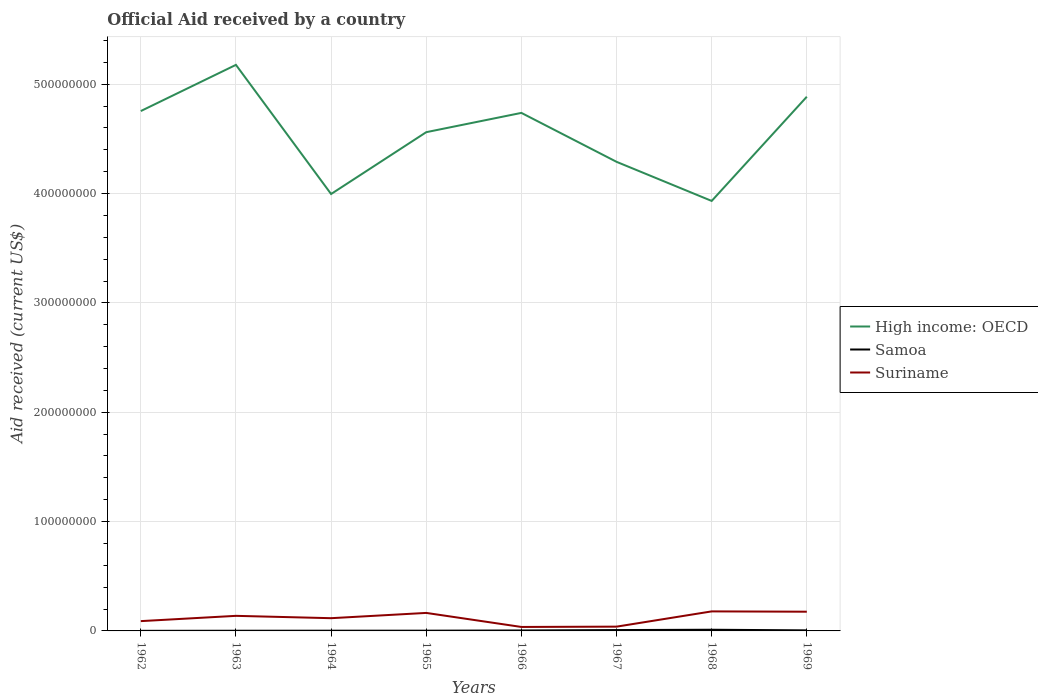How many different coloured lines are there?
Provide a short and direct response. 3. Is the number of lines equal to the number of legend labels?
Your answer should be very brief. Yes. Across all years, what is the maximum net official aid received in Samoa?
Give a very brief answer. 9.00e+04. In which year was the net official aid received in Suriname maximum?
Offer a terse response. 1966. What is the total net official aid received in Suriname in the graph?
Your answer should be very brief. -1.37e+07. What is the difference between the highest and the second highest net official aid received in Samoa?
Ensure brevity in your answer.  1.00e+06. What is the difference between the highest and the lowest net official aid received in Samoa?
Ensure brevity in your answer.  3. Is the net official aid received in High income: OECD strictly greater than the net official aid received in Suriname over the years?
Your answer should be very brief. No. How many lines are there?
Make the answer very short. 3. How many years are there in the graph?
Your response must be concise. 8. Does the graph contain grids?
Offer a very short reply. Yes. Where does the legend appear in the graph?
Give a very brief answer. Center right. How many legend labels are there?
Offer a terse response. 3. How are the legend labels stacked?
Offer a very short reply. Vertical. What is the title of the graph?
Offer a very short reply. Official Aid received by a country. Does "Tuvalu" appear as one of the legend labels in the graph?
Offer a very short reply. No. What is the label or title of the Y-axis?
Ensure brevity in your answer.  Aid received (current US$). What is the Aid received (current US$) of High income: OECD in 1962?
Provide a short and direct response. 4.75e+08. What is the Aid received (current US$) of Suriname in 1962?
Provide a succinct answer. 8.96e+06. What is the Aid received (current US$) in High income: OECD in 1963?
Ensure brevity in your answer.  5.18e+08. What is the Aid received (current US$) of Samoa in 1963?
Your answer should be very brief. 1.70e+05. What is the Aid received (current US$) in Suriname in 1963?
Provide a short and direct response. 1.38e+07. What is the Aid received (current US$) in High income: OECD in 1964?
Your answer should be very brief. 4.00e+08. What is the Aid received (current US$) of Samoa in 1964?
Provide a short and direct response. 2.10e+05. What is the Aid received (current US$) in Suriname in 1964?
Give a very brief answer. 1.16e+07. What is the Aid received (current US$) in High income: OECD in 1965?
Your answer should be compact. 4.56e+08. What is the Aid received (current US$) of Suriname in 1965?
Offer a very short reply. 1.65e+07. What is the Aid received (current US$) in High income: OECD in 1966?
Your answer should be very brief. 4.74e+08. What is the Aid received (current US$) of Suriname in 1966?
Ensure brevity in your answer.  3.63e+06. What is the Aid received (current US$) of High income: OECD in 1967?
Offer a very short reply. 4.29e+08. What is the Aid received (current US$) in Samoa in 1967?
Ensure brevity in your answer.  7.80e+05. What is the Aid received (current US$) in Suriname in 1967?
Your answer should be compact. 3.91e+06. What is the Aid received (current US$) of High income: OECD in 1968?
Keep it short and to the point. 3.93e+08. What is the Aid received (current US$) of Samoa in 1968?
Offer a terse response. 1.09e+06. What is the Aid received (current US$) in Suriname in 1968?
Ensure brevity in your answer.  1.79e+07. What is the Aid received (current US$) of High income: OECD in 1969?
Ensure brevity in your answer.  4.89e+08. What is the Aid received (current US$) of Samoa in 1969?
Keep it short and to the point. 5.10e+05. What is the Aid received (current US$) of Suriname in 1969?
Give a very brief answer. 1.76e+07. Across all years, what is the maximum Aid received (current US$) of High income: OECD?
Offer a very short reply. 5.18e+08. Across all years, what is the maximum Aid received (current US$) of Samoa?
Your answer should be compact. 1.09e+06. Across all years, what is the maximum Aid received (current US$) of Suriname?
Make the answer very short. 1.79e+07. Across all years, what is the minimum Aid received (current US$) of High income: OECD?
Give a very brief answer. 3.93e+08. Across all years, what is the minimum Aid received (current US$) in Samoa?
Ensure brevity in your answer.  9.00e+04. Across all years, what is the minimum Aid received (current US$) of Suriname?
Ensure brevity in your answer.  3.63e+06. What is the total Aid received (current US$) in High income: OECD in the graph?
Your response must be concise. 3.63e+09. What is the total Aid received (current US$) in Samoa in the graph?
Offer a very short reply. 3.50e+06. What is the total Aid received (current US$) of Suriname in the graph?
Ensure brevity in your answer.  9.38e+07. What is the difference between the Aid received (current US$) of High income: OECD in 1962 and that in 1963?
Your answer should be very brief. -4.22e+07. What is the difference between the Aid received (current US$) of Suriname in 1962 and that in 1963?
Provide a succinct answer. -4.83e+06. What is the difference between the Aid received (current US$) of High income: OECD in 1962 and that in 1964?
Give a very brief answer. 7.59e+07. What is the difference between the Aid received (current US$) of Samoa in 1962 and that in 1964?
Make the answer very short. -1.20e+05. What is the difference between the Aid received (current US$) of Suriname in 1962 and that in 1964?
Offer a very short reply. -2.69e+06. What is the difference between the Aid received (current US$) of High income: OECD in 1962 and that in 1965?
Your answer should be compact. 1.93e+07. What is the difference between the Aid received (current US$) in Suriname in 1962 and that in 1965?
Keep it short and to the point. -7.51e+06. What is the difference between the Aid received (current US$) in High income: OECD in 1962 and that in 1966?
Make the answer very short. 1.68e+06. What is the difference between the Aid received (current US$) of Samoa in 1962 and that in 1966?
Your answer should be very brief. -3.30e+05. What is the difference between the Aid received (current US$) in Suriname in 1962 and that in 1966?
Keep it short and to the point. 5.33e+06. What is the difference between the Aid received (current US$) in High income: OECD in 1962 and that in 1967?
Provide a short and direct response. 4.64e+07. What is the difference between the Aid received (current US$) in Samoa in 1962 and that in 1967?
Provide a short and direct response. -6.90e+05. What is the difference between the Aid received (current US$) of Suriname in 1962 and that in 1967?
Your response must be concise. 5.05e+06. What is the difference between the Aid received (current US$) in High income: OECD in 1962 and that in 1968?
Make the answer very short. 8.22e+07. What is the difference between the Aid received (current US$) of Samoa in 1962 and that in 1968?
Your response must be concise. -1.00e+06. What is the difference between the Aid received (current US$) of Suriname in 1962 and that in 1968?
Provide a short and direct response. -8.90e+06. What is the difference between the Aid received (current US$) of High income: OECD in 1962 and that in 1969?
Make the answer very short. -1.31e+07. What is the difference between the Aid received (current US$) in Samoa in 1962 and that in 1969?
Keep it short and to the point. -4.20e+05. What is the difference between the Aid received (current US$) of Suriname in 1962 and that in 1969?
Your answer should be very brief. -8.62e+06. What is the difference between the Aid received (current US$) of High income: OECD in 1963 and that in 1964?
Your answer should be compact. 1.18e+08. What is the difference between the Aid received (current US$) of Samoa in 1963 and that in 1964?
Your answer should be very brief. -4.00e+04. What is the difference between the Aid received (current US$) in Suriname in 1963 and that in 1964?
Give a very brief answer. 2.14e+06. What is the difference between the Aid received (current US$) of High income: OECD in 1963 and that in 1965?
Offer a terse response. 6.16e+07. What is the difference between the Aid received (current US$) of Suriname in 1963 and that in 1965?
Your answer should be very brief. -2.68e+06. What is the difference between the Aid received (current US$) of High income: OECD in 1963 and that in 1966?
Provide a short and direct response. 4.39e+07. What is the difference between the Aid received (current US$) in Samoa in 1963 and that in 1966?
Your response must be concise. -2.50e+05. What is the difference between the Aid received (current US$) in Suriname in 1963 and that in 1966?
Your answer should be compact. 1.02e+07. What is the difference between the Aid received (current US$) of High income: OECD in 1963 and that in 1967?
Ensure brevity in your answer.  8.87e+07. What is the difference between the Aid received (current US$) in Samoa in 1963 and that in 1967?
Your response must be concise. -6.10e+05. What is the difference between the Aid received (current US$) in Suriname in 1963 and that in 1967?
Ensure brevity in your answer.  9.88e+06. What is the difference between the Aid received (current US$) of High income: OECD in 1963 and that in 1968?
Ensure brevity in your answer.  1.24e+08. What is the difference between the Aid received (current US$) in Samoa in 1963 and that in 1968?
Give a very brief answer. -9.20e+05. What is the difference between the Aid received (current US$) of Suriname in 1963 and that in 1968?
Give a very brief answer. -4.07e+06. What is the difference between the Aid received (current US$) of High income: OECD in 1963 and that in 1969?
Your response must be concise. 2.91e+07. What is the difference between the Aid received (current US$) of Suriname in 1963 and that in 1969?
Provide a succinct answer. -3.79e+06. What is the difference between the Aid received (current US$) of High income: OECD in 1964 and that in 1965?
Ensure brevity in your answer.  -5.66e+07. What is the difference between the Aid received (current US$) of Suriname in 1964 and that in 1965?
Your answer should be very brief. -4.82e+06. What is the difference between the Aid received (current US$) of High income: OECD in 1964 and that in 1966?
Provide a succinct answer. -7.42e+07. What is the difference between the Aid received (current US$) of Suriname in 1964 and that in 1966?
Provide a short and direct response. 8.02e+06. What is the difference between the Aid received (current US$) in High income: OECD in 1964 and that in 1967?
Your response must be concise. -2.94e+07. What is the difference between the Aid received (current US$) of Samoa in 1964 and that in 1967?
Give a very brief answer. -5.70e+05. What is the difference between the Aid received (current US$) of Suriname in 1964 and that in 1967?
Your response must be concise. 7.74e+06. What is the difference between the Aid received (current US$) in High income: OECD in 1964 and that in 1968?
Your response must be concise. 6.33e+06. What is the difference between the Aid received (current US$) in Samoa in 1964 and that in 1968?
Your answer should be compact. -8.80e+05. What is the difference between the Aid received (current US$) in Suriname in 1964 and that in 1968?
Provide a succinct answer. -6.21e+06. What is the difference between the Aid received (current US$) in High income: OECD in 1964 and that in 1969?
Provide a succinct answer. -8.90e+07. What is the difference between the Aid received (current US$) in Suriname in 1964 and that in 1969?
Your response must be concise. -5.93e+06. What is the difference between the Aid received (current US$) in High income: OECD in 1965 and that in 1966?
Your answer should be compact. -1.76e+07. What is the difference between the Aid received (current US$) in Suriname in 1965 and that in 1966?
Ensure brevity in your answer.  1.28e+07. What is the difference between the Aid received (current US$) in High income: OECD in 1965 and that in 1967?
Give a very brief answer. 2.71e+07. What is the difference between the Aid received (current US$) in Samoa in 1965 and that in 1967?
Offer a very short reply. -5.50e+05. What is the difference between the Aid received (current US$) of Suriname in 1965 and that in 1967?
Your response must be concise. 1.26e+07. What is the difference between the Aid received (current US$) in High income: OECD in 1965 and that in 1968?
Provide a succinct answer. 6.29e+07. What is the difference between the Aid received (current US$) of Samoa in 1965 and that in 1968?
Offer a terse response. -8.60e+05. What is the difference between the Aid received (current US$) in Suriname in 1965 and that in 1968?
Ensure brevity in your answer.  -1.39e+06. What is the difference between the Aid received (current US$) of High income: OECD in 1965 and that in 1969?
Ensure brevity in your answer.  -3.24e+07. What is the difference between the Aid received (current US$) in Samoa in 1965 and that in 1969?
Keep it short and to the point. -2.80e+05. What is the difference between the Aid received (current US$) of Suriname in 1965 and that in 1969?
Offer a very short reply. -1.11e+06. What is the difference between the Aid received (current US$) in High income: OECD in 1966 and that in 1967?
Your answer should be very brief. 4.48e+07. What is the difference between the Aid received (current US$) in Samoa in 1966 and that in 1967?
Ensure brevity in your answer.  -3.60e+05. What is the difference between the Aid received (current US$) of Suriname in 1966 and that in 1967?
Your answer should be very brief. -2.80e+05. What is the difference between the Aid received (current US$) of High income: OECD in 1966 and that in 1968?
Give a very brief answer. 8.05e+07. What is the difference between the Aid received (current US$) in Samoa in 1966 and that in 1968?
Provide a succinct answer. -6.70e+05. What is the difference between the Aid received (current US$) of Suriname in 1966 and that in 1968?
Give a very brief answer. -1.42e+07. What is the difference between the Aid received (current US$) in High income: OECD in 1966 and that in 1969?
Your response must be concise. -1.48e+07. What is the difference between the Aid received (current US$) in Suriname in 1966 and that in 1969?
Your answer should be very brief. -1.40e+07. What is the difference between the Aid received (current US$) of High income: OECD in 1967 and that in 1968?
Your answer should be very brief. 3.58e+07. What is the difference between the Aid received (current US$) of Samoa in 1967 and that in 1968?
Offer a terse response. -3.10e+05. What is the difference between the Aid received (current US$) in Suriname in 1967 and that in 1968?
Ensure brevity in your answer.  -1.40e+07. What is the difference between the Aid received (current US$) of High income: OECD in 1967 and that in 1969?
Offer a very short reply. -5.95e+07. What is the difference between the Aid received (current US$) in Samoa in 1967 and that in 1969?
Your answer should be very brief. 2.70e+05. What is the difference between the Aid received (current US$) of Suriname in 1967 and that in 1969?
Provide a succinct answer. -1.37e+07. What is the difference between the Aid received (current US$) in High income: OECD in 1968 and that in 1969?
Offer a terse response. -9.53e+07. What is the difference between the Aid received (current US$) of Samoa in 1968 and that in 1969?
Provide a short and direct response. 5.80e+05. What is the difference between the Aid received (current US$) of High income: OECD in 1962 and the Aid received (current US$) of Samoa in 1963?
Offer a terse response. 4.75e+08. What is the difference between the Aid received (current US$) in High income: OECD in 1962 and the Aid received (current US$) in Suriname in 1963?
Your answer should be compact. 4.62e+08. What is the difference between the Aid received (current US$) in Samoa in 1962 and the Aid received (current US$) in Suriname in 1963?
Provide a succinct answer. -1.37e+07. What is the difference between the Aid received (current US$) of High income: OECD in 1962 and the Aid received (current US$) of Samoa in 1964?
Provide a succinct answer. 4.75e+08. What is the difference between the Aid received (current US$) in High income: OECD in 1962 and the Aid received (current US$) in Suriname in 1964?
Keep it short and to the point. 4.64e+08. What is the difference between the Aid received (current US$) of Samoa in 1962 and the Aid received (current US$) of Suriname in 1964?
Keep it short and to the point. -1.16e+07. What is the difference between the Aid received (current US$) in High income: OECD in 1962 and the Aid received (current US$) in Samoa in 1965?
Keep it short and to the point. 4.75e+08. What is the difference between the Aid received (current US$) in High income: OECD in 1962 and the Aid received (current US$) in Suriname in 1965?
Your response must be concise. 4.59e+08. What is the difference between the Aid received (current US$) in Samoa in 1962 and the Aid received (current US$) in Suriname in 1965?
Provide a succinct answer. -1.64e+07. What is the difference between the Aid received (current US$) in High income: OECD in 1962 and the Aid received (current US$) in Samoa in 1966?
Offer a very short reply. 4.75e+08. What is the difference between the Aid received (current US$) of High income: OECD in 1962 and the Aid received (current US$) of Suriname in 1966?
Your answer should be compact. 4.72e+08. What is the difference between the Aid received (current US$) in Samoa in 1962 and the Aid received (current US$) in Suriname in 1966?
Offer a terse response. -3.54e+06. What is the difference between the Aid received (current US$) of High income: OECD in 1962 and the Aid received (current US$) of Samoa in 1967?
Keep it short and to the point. 4.75e+08. What is the difference between the Aid received (current US$) of High income: OECD in 1962 and the Aid received (current US$) of Suriname in 1967?
Ensure brevity in your answer.  4.72e+08. What is the difference between the Aid received (current US$) of Samoa in 1962 and the Aid received (current US$) of Suriname in 1967?
Make the answer very short. -3.82e+06. What is the difference between the Aid received (current US$) in High income: OECD in 1962 and the Aid received (current US$) in Samoa in 1968?
Your answer should be compact. 4.74e+08. What is the difference between the Aid received (current US$) in High income: OECD in 1962 and the Aid received (current US$) in Suriname in 1968?
Your response must be concise. 4.58e+08. What is the difference between the Aid received (current US$) in Samoa in 1962 and the Aid received (current US$) in Suriname in 1968?
Your answer should be very brief. -1.78e+07. What is the difference between the Aid received (current US$) of High income: OECD in 1962 and the Aid received (current US$) of Samoa in 1969?
Your answer should be compact. 4.75e+08. What is the difference between the Aid received (current US$) in High income: OECD in 1962 and the Aid received (current US$) in Suriname in 1969?
Your answer should be very brief. 4.58e+08. What is the difference between the Aid received (current US$) in Samoa in 1962 and the Aid received (current US$) in Suriname in 1969?
Keep it short and to the point. -1.75e+07. What is the difference between the Aid received (current US$) of High income: OECD in 1963 and the Aid received (current US$) of Samoa in 1964?
Your answer should be very brief. 5.18e+08. What is the difference between the Aid received (current US$) in High income: OECD in 1963 and the Aid received (current US$) in Suriname in 1964?
Your answer should be compact. 5.06e+08. What is the difference between the Aid received (current US$) in Samoa in 1963 and the Aid received (current US$) in Suriname in 1964?
Your answer should be compact. -1.15e+07. What is the difference between the Aid received (current US$) in High income: OECD in 1963 and the Aid received (current US$) in Samoa in 1965?
Give a very brief answer. 5.18e+08. What is the difference between the Aid received (current US$) in High income: OECD in 1963 and the Aid received (current US$) in Suriname in 1965?
Provide a succinct answer. 5.01e+08. What is the difference between the Aid received (current US$) of Samoa in 1963 and the Aid received (current US$) of Suriname in 1965?
Offer a terse response. -1.63e+07. What is the difference between the Aid received (current US$) of High income: OECD in 1963 and the Aid received (current US$) of Samoa in 1966?
Offer a very short reply. 5.17e+08. What is the difference between the Aid received (current US$) of High income: OECD in 1963 and the Aid received (current US$) of Suriname in 1966?
Provide a short and direct response. 5.14e+08. What is the difference between the Aid received (current US$) in Samoa in 1963 and the Aid received (current US$) in Suriname in 1966?
Offer a terse response. -3.46e+06. What is the difference between the Aid received (current US$) of High income: OECD in 1963 and the Aid received (current US$) of Samoa in 1967?
Offer a very short reply. 5.17e+08. What is the difference between the Aid received (current US$) of High income: OECD in 1963 and the Aid received (current US$) of Suriname in 1967?
Make the answer very short. 5.14e+08. What is the difference between the Aid received (current US$) in Samoa in 1963 and the Aid received (current US$) in Suriname in 1967?
Your response must be concise. -3.74e+06. What is the difference between the Aid received (current US$) of High income: OECD in 1963 and the Aid received (current US$) of Samoa in 1968?
Your answer should be compact. 5.17e+08. What is the difference between the Aid received (current US$) of High income: OECD in 1963 and the Aid received (current US$) of Suriname in 1968?
Provide a short and direct response. 5.00e+08. What is the difference between the Aid received (current US$) of Samoa in 1963 and the Aid received (current US$) of Suriname in 1968?
Ensure brevity in your answer.  -1.77e+07. What is the difference between the Aid received (current US$) of High income: OECD in 1963 and the Aid received (current US$) of Samoa in 1969?
Provide a succinct answer. 5.17e+08. What is the difference between the Aid received (current US$) in High income: OECD in 1963 and the Aid received (current US$) in Suriname in 1969?
Give a very brief answer. 5.00e+08. What is the difference between the Aid received (current US$) in Samoa in 1963 and the Aid received (current US$) in Suriname in 1969?
Your response must be concise. -1.74e+07. What is the difference between the Aid received (current US$) in High income: OECD in 1964 and the Aid received (current US$) in Samoa in 1965?
Keep it short and to the point. 3.99e+08. What is the difference between the Aid received (current US$) in High income: OECD in 1964 and the Aid received (current US$) in Suriname in 1965?
Provide a succinct answer. 3.83e+08. What is the difference between the Aid received (current US$) of Samoa in 1964 and the Aid received (current US$) of Suriname in 1965?
Your answer should be very brief. -1.63e+07. What is the difference between the Aid received (current US$) in High income: OECD in 1964 and the Aid received (current US$) in Samoa in 1966?
Give a very brief answer. 3.99e+08. What is the difference between the Aid received (current US$) in High income: OECD in 1964 and the Aid received (current US$) in Suriname in 1966?
Your response must be concise. 3.96e+08. What is the difference between the Aid received (current US$) of Samoa in 1964 and the Aid received (current US$) of Suriname in 1966?
Offer a very short reply. -3.42e+06. What is the difference between the Aid received (current US$) of High income: OECD in 1964 and the Aid received (current US$) of Samoa in 1967?
Your answer should be very brief. 3.99e+08. What is the difference between the Aid received (current US$) of High income: OECD in 1964 and the Aid received (current US$) of Suriname in 1967?
Your answer should be compact. 3.96e+08. What is the difference between the Aid received (current US$) of Samoa in 1964 and the Aid received (current US$) of Suriname in 1967?
Give a very brief answer. -3.70e+06. What is the difference between the Aid received (current US$) of High income: OECD in 1964 and the Aid received (current US$) of Samoa in 1968?
Your answer should be very brief. 3.99e+08. What is the difference between the Aid received (current US$) in High income: OECD in 1964 and the Aid received (current US$) in Suriname in 1968?
Your response must be concise. 3.82e+08. What is the difference between the Aid received (current US$) of Samoa in 1964 and the Aid received (current US$) of Suriname in 1968?
Provide a succinct answer. -1.76e+07. What is the difference between the Aid received (current US$) in High income: OECD in 1964 and the Aid received (current US$) in Samoa in 1969?
Give a very brief answer. 3.99e+08. What is the difference between the Aid received (current US$) of High income: OECD in 1964 and the Aid received (current US$) of Suriname in 1969?
Offer a terse response. 3.82e+08. What is the difference between the Aid received (current US$) of Samoa in 1964 and the Aid received (current US$) of Suriname in 1969?
Give a very brief answer. -1.74e+07. What is the difference between the Aid received (current US$) in High income: OECD in 1965 and the Aid received (current US$) in Samoa in 1966?
Your response must be concise. 4.56e+08. What is the difference between the Aid received (current US$) in High income: OECD in 1965 and the Aid received (current US$) in Suriname in 1966?
Your answer should be very brief. 4.53e+08. What is the difference between the Aid received (current US$) in Samoa in 1965 and the Aid received (current US$) in Suriname in 1966?
Your answer should be compact. -3.40e+06. What is the difference between the Aid received (current US$) of High income: OECD in 1965 and the Aid received (current US$) of Samoa in 1967?
Keep it short and to the point. 4.55e+08. What is the difference between the Aid received (current US$) of High income: OECD in 1965 and the Aid received (current US$) of Suriname in 1967?
Ensure brevity in your answer.  4.52e+08. What is the difference between the Aid received (current US$) in Samoa in 1965 and the Aid received (current US$) in Suriname in 1967?
Your answer should be very brief. -3.68e+06. What is the difference between the Aid received (current US$) in High income: OECD in 1965 and the Aid received (current US$) in Samoa in 1968?
Give a very brief answer. 4.55e+08. What is the difference between the Aid received (current US$) of High income: OECD in 1965 and the Aid received (current US$) of Suriname in 1968?
Provide a succinct answer. 4.38e+08. What is the difference between the Aid received (current US$) of Samoa in 1965 and the Aid received (current US$) of Suriname in 1968?
Your answer should be very brief. -1.76e+07. What is the difference between the Aid received (current US$) in High income: OECD in 1965 and the Aid received (current US$) in Samoa in 1969?
Offer a terse response. 4.56e+08. What is the difference between the Aid received (current US$) of High income: OECD in 1965 and the Aid received (current US$) of Suriname in 1969?
Give a very brief answer. 4.39e+08. What is the difference between the Aid received (current US$) of Samoa in 1965 and the Aid received (current US$) of Suriname in 1969?
Provide a short and direct response. -1.74e+07. What is the difference between the Aid received (current US$) in High income: OECD in 1966 and the Aid received (current US$) in Samoa in 1967?
Your answer should be compact. 4.73e+08. What is the difference between the Aid received (current US$) of High income: OECD in 1966 and the Aid received (current US$) of Suriname in 1967?
Offer a terse response. 4.70e+08. What is the difference between the Aid received (current US$) of Samoa in 1966 and the Aid received (current US$) of Suriname in 1967?
Provide a succinct answer. -3.49e+06. What is the difference between the Aid received (current US$) of High income: OECD in 1966 and the Aid received (current US$) of Samoa in 1968?
Keep it short and to the point. 4.73e+08. What is the difference between the Aid received (current US$) of High income: OECD in 1966 and the Aid received (current US$) of Suriname in 1968?
Keep it short and to the point. 4.56e+08. What is the difference between the Aid received (current US$) of Samoa in 1966 and the Aid received (current US$) of Suriname in 1968?
Offer a terse response. -1.74e+07. What is the difference between the Aid received (current US$) in High income: OECD in 1966 and the Aid received (current US$) in Samoa in 1969?
Provide a succinct answer. 4.73e+08. What is the difference between the Aid received (current US$) in High income: OECD in 1966 and the Aid received (current US$) in Suriname in 1969?
Your response must be concise. 4.56e+08. What is the difference between the Aid received (current US$) in Samoa in 1966 and the Aid received (current US$) in Suriname in 1969?
Your response must be concise. -1.72e+07. What is the difference between the Aid received (current US$) in High income: OECD in 1967 and the Aid received (current US$) in Samoa in 1968?
Your answer should be compact. 4.28e+08. What is the difference between the Aid received (current US$) in High income: OECD in 1967 and the Aid received (current US$) in Suriname in 1968?
Your response must be concise. 4.11e+08. What is the difference between the Aid received (current US$) in Samoa in 1967 and the Aid received (current US$) in Suriname in 1968?
Provide a short and direct response. -1.71e+07. What is the difference between the Aid received (current US$) of High income: OECD in 1967 and the Aid received (current US$) of Samoa in 1969?
Offer a terse response. 4.29e+08. What is the difference between the Aid received (current US$) of High income: OECD in 1967 and the Aid received (current US$) of Suriname in 1969?
Your response must be concise. 4.11e+08. What is the difference between the Aid received (current US$) in Samoa in 1967 and the Aid received (current US$) in Suriname in 1969?
Provide a succinct answer. -1.68e+07. What is the difference between the Aid received (current US$) of High income: OECD in 1968 and the Aid received (current US$) of Samoa in 1969?
Give a very brief answer. 3.93e+08. What is the difference between the Aid received (current US$) of High income: OECD in 1968 and the Aid received (current US$) of Suriname in 1969?
Ensure brevity in your answer.  3.76e+08. What is the difference between the Aid received (current US$) in Samoa in 1968 and the Aid received (current US$) in Suriname in 1969?
Offer a very short reply. -1.65e+07. What is the average Aid received (current US$) in High income: OECD per year?
Keep it short and to the point. 4.54e+08. What is the average Aid received (current US$) in Samoa per year?
Your answer should be compact. 4.38e+05. What is the average Aid received (current US$) of Suriname per year?
Provide a succinct answer. 1.17e+07. In the year 1962, what is the difference between the Aid received (current US$) of High income: OECD and Aid received (current US$) of Samoa?
Give a very brief answer. 4.75e+08. In the year 1962, what is the difference between the Aid received (current US$) in High income: OECD and Aid received (current US$) in Suriname?
Make the answer very short. 4.67e+08. In the year 1962, what is the difference between the Aid received (current US$) of Samoa and Aid received (current US$) of Suriname?
Provide a short and direct response. -8.87e+06. In the year 1963, what is the difference between the Aid received (current US$) of High income: OECD and Aid received (current US$) of Samoa?
Offer a terse response. 5.18e+08. In the year 1963, what is the difference between the Aid received (current US$) in High income: OECD and Aid received (current US$) in Suriname?
Give a very brief answer. 5.04e+08. In the year 1963, what is the difference between the Aid received (current US$) of Samoa and Aid received (current US$) of Suriname?
Your answer should be compact. -1.36e+07. In the year 1964, what is the difference between the Aid received (current US$) of High income: OECD and Aid received (current US$) of Samoa?
Ensure brevity in your answer.  3.99e+08. In the year 1964, what is the difference between the Aid received (current US$) in High income: OECD and Aid received (current US$) in Suriname?
Keep it short and to the point. 3.88e+08. In the year 1964, what is the difference between the Aid received (current US$) in Samoa and Aid received (current US$) in Suriname?
Provide a short and direct response. -1.14e+07. In the year 1965, what is the difference between the Aid received (current US$) in High income: OECD and Aid received (current US$) in Samoa?
Keep it short and to the point. 4.56e+08. In the year 1965, what is the difference between the Aid received (current US$) of High income: OECD and Aid received (current US$) of Suriname?
Your response must be concise. 4.40e+08. In the year 1965, what is the difference between the Aid received (current US$) of Samoa and Aid received (current US$) of Suriname?
Your answer should be very brief. -1.62e+07. In the year 1966, what is the difference between the Aid received (current US$) of High income: OECD and Aid received (current US$) of Samoa?
Offer a terse response. 4.73e+08. In the year 1966, what is the difference between the Aid received (current US$) of High income: OECD and Aid received (current US$) of Suriname?
Provide a short and direct response. 4.70e+08. In the year 1966, what is the difference between the Aid received (current US$) in Samoa and Aid received (current US$) in Suriname?
Keep it short and to the point. -3.21e+06. In the year 1967, what is the difference between the Aid received (current US$) in High income: OECD and Aid received (current US$) in Samoa?
Offer a terse response. 4.28e+08. In the year 1967, what is the difference between the Aid received (current US$) of High income: OECD and Aid received (current US$) of Suriname?
Keep it short and to the point. 4.25e+08. In the year 1967, what is the difference between the Aid received (current US$) of Samoa and Aid received (current US$) of Suriname?
Provide a short and direct response. -3.13e+06. In the year 1968, what is the difference between the Aid received (current US$) of High income: OECD and Aid received (current US$) of Samoa?
Provide a short and direct response. 3.92e+08. In the year 1968, what is the difference between the Aid received (current US$) in High income: OECD and Aid received (current US$) in Suriname?
Provide a succinct answer. 3.75e+08. In the year 1968, what is the difference between the Aid received (current US$) of Samoa and Aid received (current US$) of Suriname?
Your answer should be very brief. -1.68e+07. In the year 1969, what is the difference between the Aid received (current US$) of High income: OECD and Aid received (current US$) of Samoa?
Your answer should be very brief. 4.88e+08. In the year 1969, what is the difference between the Aid received (current US$) of High income: OECD and Aid received (current US$) of Suriname?
Keep it short and to the point. 4.71e+08. In the year 1969, what is the difference between the Aid received (current US$) in Samoa and Aid received (current US$) in Suriname?
Offer a very short reply. -1.71e+07. What is the ratio of the Aid received (current US$) in High income: OECD in 1962 to that in 1963?
Your response must be concise. 0.92. What is the ratio of the Aid received (current US$) in Samoa in 1962 to that in 1963?
Keep it short and to the point. 0.53. What is the ratio of the Aid received (current US$) of Suriname in 1962 to that in 1963?
Ensure brevity in your answer.  0.65. What is the ratio of the Aid received (current US$) of High income: OECD in 1962 to that in 1964?
Provide a short and direct response. 1.19. What is the ratio of the Aid received (current US$) in Samoa in 1962 to that in 1964?
Offer a terse response. 0.43. What is the ratio of the Aid received (current US$) in Suriname in 1962 to that in 1964?
Provide a succinct answer. 0.77. What is the ratio of the Aid received (current US$) in High income: OECD in 1962 to that in 1965?
Your answer should be very brief. 1.04. What is the ratio of the Aid received (current US$) in Samoa in 1962 to that in 1965?
Offer a very short reply. 0.39. What is the ratio of the Aid received (current US$) in Suriname in 1962 to that in 1965?
Provide a short and direct response. 0.54. What is the ratio of the Aid received (current US$) of High income: OECD in 1962 to that in 1966?
Your answer should be very brief. 1. What is the ratio of the Aid received (current US$) in Samoa in 1962 to that in 1966?
Ensure brevity in your answer.  0.21. What is the ratio of the Aid received (current US$) in Suriname in 1962 to that in 1966?
Your answer should be very brief. 2.47. What is the ratio of the Aid received (current US$) of High income: OECD in 1962 to that in 1967?
Your response must be concise. 1.11. What is the ratio of the Aid received (current US$) in Samoa in 1962 to that in 1967?
Give a very brief answer. 0.12. What is the ratio of the Aid received (current US$) in Suriname in 1962 to that in 1967?
Offer a terse response. 2.29. What is the ratio of the Aid received (current US$) of High income: OECD in 1962 to that in 1968?
Provide a succinct answer. 1.21. What is the ratio of the Aid received (current US$) in Samoa in 1962 to that in 1968?
Provide a short and direct response. 0.08. What is the ratio of the Aid received (current US$) in Suriname in 1962 to that in 1968?
Give a very brief answer. 0.5. What is the ratio of the Aid received (current US$) in High income: OECD in 1962 to that in 1969?
Provide a succinct answer. 0.97. What is the ratio of the Aid received (current US$) in Samoa in 1962 to that in 1969?
Give a very brief answer. 0.18. What is the ratio of the Aid received (current US$) in Suriname in 1962 to that in 1969?
Make the answer very short. 0.51. What is the ratio of the Aid received (current US$) of High income: OECD in 1963 to that in 1964?
Provide a short and direct response. 1.3. What is the ratio of the Aid received (current US$) of Samoa in 1963 to that in 1964?
Make the answer very short. 0.81. What is the ratio of the Aid received (current US$) of Suriname in 1963 to that in 1964?
Ensure brevity in your answer.  1.18. What is the ratio of the Aid received (current US$) of High income: OECD in 1963 to that in 1965?
Keep it short and to the point. 1.13. What is the ratio of the Aid received (current US$) in Samoa in 1963 to that in 1965?
Provide a succinct answer. 0.74. What is the ratio of the Aid received (current US$) in Suriname in 1963 to that in 1965?
Offer a terse response. 0.84. What is the ratio of the Aid received (current US$) in High income: OECD in 1963 to that in 1966?
Your answer should be compact. 1.09. What is the ratio of the Aid received (current US$) in Samoa in 1963 to that in 1966?
Provide a succinct answer. 0.4. What is the ratio of the Aid received (current US$) in Suriname in 1963 to that in 1966?
Keep it short and to the point. 3.8. What is the ratio of the Aid received (current US$) in High income: OECD in 1963 to that in 1967?
Offer a terse response. 1.21. What is the ratio of the Aid received (current US$) of Samoa in 1963 to that in 1967?
Ensure brevity in your answer.  0.22. What is the ratio of the Aid received (current US$) in Suriname in 1963 to that in 1967?
Your answer should be compact. 3.53. What is the ratio of the Aid received (current US$) in High income: OECD in 1963 to that in 1968?
Provide a succinct answer. 1.32. What is the ratio of the Aid received (current US$) of Samoa in 1963 to that in 1968?
Give a very brief answer. 0.16. What is the ratio of the Aid received (current US$) of Suriname in 1963 to that in 1968?
Offer a terse response. 0.77. What is the ratio of the Aid received (current US$) in High income: OECD in 1963 to that in 1969?
Your response must be concise. 1.06. What is the ratio of the Aid received (current US$) in Samoa in 1963 to that in 1969?
Provide a succinct answer. 0.33. What is the ratio of the Aid received (current US$) in Suriname in 1963 to that in 1969?
Your answer should be very brief. 0.78. What is the ratio of the Aid received (current US$) in High income: OECD in 1964 to that in 1965?
Make the answer very short. 0.88. What is the ratio of the Aid received (current US$) in Suriname in 1964 to that in 1965?
Your answer should be very brief. 0.71. What is the ratio of the Aid received (current US$) in High income: OECD in 1964 to that in 1966?
Offer a very short reply. 0.84. What is the ratio of the Aid received (current US$) of Suriname in 1964 to that in 1966?
Provide a short and direct response. 3.21. What is the ratio of the Aid received (current US$) of High income: OECD in 1964 to that in 1967?
Your response must be concise. 0.93. What is the ratio of the Aid received (current US$) of Samoa in 1964 to that in 1967?
Ensure brevity in your answer.  0.27. What is the ratio of the Aid received (current US$) of Suriname in 1964 to that in 1967?
Offer a terse response. 2.98. What is the ratio of the Aid received (current US$) in High income: OECD in 1964 to that in 1968?
Offer a terse response. 1.02. What is the ratio of the Aid received (current US$) in Samoa in 1964 to that in 1968?
Make the answer very short. 0.19. What is the ratio of the Aid received (current US$) of Suriname in 1964 to that in 1968?
Your answer should be compact. 0.65. What is the ratio of the Aid received (current US$) of High income: OECD in 1964 to that in 1969?
Provide a short and direct response. 0.82. What is the ratio of the Aid received (current US$) of Samoa in 1964 to that in 1969?
Your answer should be very brief. 0.41. What is the ratio of the Aid received (current US$) of Suriname in 1964 to that in 1969?
Offer a terse response. 0.66. What is the ratio of the Aid received (current US$) of High income: OECD in 1965 to that in 1966?
Make the answer very short. 0.96. What is the ratio of the Aid received (current US$) of Samoa in 1965 to that in 1966?
Provide a succinct answer. 0.55. What is the ratio of the Aid received (current US$) in Suriname in 1965 to that in 1966?
Offer a terse response. 4.54. What is the ratio of the Aid received (current US$) of High income: OECD in 1965 to that in 1967?
Your response must be concise. 1.06. What is the ratio of the Aid received (current US$) in Samoa in 1965 to that in 1967?
Your answer should be compact. 0.29. What is the ratio of the Aid received (current US$) of Suriname in 1965 to that in 1967?
Make the answer very short. 4.21. What is the ratio of the Aid received (current US$) in High income: OECD in 1965 to that in 1968?
Give a very brief answer. 1.16. What is the ratio of the Aid received (current US$) in Samoa in 1965 to that in 1968?
Your response must be concise. 0.21. What is the ratio of the Aid received (current US$) of Suriname in 1965 to that in 1968?
Provide a succinct answer. 0.92. What is the ratio of the Aid received (current US$) in High income: OECD in 1965 to that in 1969?
Your answer should be very brief. 0.93. What is the ratio of the Aid received (current US$) in Samoa in 1965 to that in 1969?
Offer a very short reply. 0.45. What is the ratio of the Aid received (current US$) of Suriname in 1965 to that in 1969?
Make the answer very short. 0.94. What is the ratio of the Aid received (current US$) of High income: OECD in 1966 to that in 1967?
Provide a short and direct response. 1.1. What is the ratio of the Aid received (current US$) of Samoa in 1966 to that in 1967?
Your answer should be very brief. 0.54. What is the ratio of the Aid received (current US$) in Suriname in 1966 to that in 1967?
Make the answer very short. 0.93. What is the ratio of the Aid received (current US$) in High income: OECD in 1966 to that in 1968?
Ensure brevity in your answer.  1.2. What is the ratio of the Aid received (current US$) in Samoa in 1966 to that in 1968?
Offer a terse response. 0.39. What is the ratio of the Aid received (current US$) in Suriname in 1966 to that in 1968?
Offer a terse response. 0.2. What is the ratio of the Aid received (current US$) in High income: OECD in 1966 to that in 1969?
Make the answer very short. 0.97. What is the ratio of the Aid received (current US$) in Samoa in 1966 to that in 1969?
Keep it short and to the point. 0.82. What is the ratio of the Aid received (current US$) in Suriname in 1966 to that in 1969?
Keep it short and to the point. 0.21. What is the ratio of the Aid received (current US$) in High income: OECD in 1967 to that in 1968?
Your response must be concise. 1.09. What is the ratio of the Aid received (current US$) of Samoa in 1967 to that in 1968?
Offer a terse response. 0.72. What is the ratio of the Aid received (current US$) of Suriname in 1967 to that in 1968?
Keep it short and to the point. 0.22. What is the ratio of the Aid received (current US$) of High income: OECD in 1967 to that in 1969?
Offer a very short reply. 0.88. What is the ratio of the Aid received (current US$) in Samoa in 1967 to that in 1969?
Provide a short and direct response. 1.53. What is the ratio of the Aid received (current US$) of Suriname in 1967 to that in 1969?
Ensure brevity in your answer.  0.22. What is the ratio of the Aid received (current US$) of High income: OECD in 1968 to that in 1969?
Your answer should be very brief. 0.8. What is the ratio of the Aid received (current US$) in Samoa in 1968 to that in 1969?
Offer a terse response. 2.14. What is the ratio of the Aid received (current US$) in Suriname in 1968 to that in 1969?
Offer a very short reply. 1.02. What is the difference between the highest and the second highest Aid received (current US$) in High income: OECD?
Ensure brevity in your answer.  2.91e+07. What is the difference between the highest and the lowest Aid received (current US$) of High income: OECD?
Offer a terse response. 1.24e+08. What is the difference between the highest and the lowest Aid received (current US$) of Samoa?
Offer a very short reply. 1.00e+06. What is the difference between the highest and the lowest Aid received (current US$) in Suriname?
Offer a very short reply. 1.42e+07. 